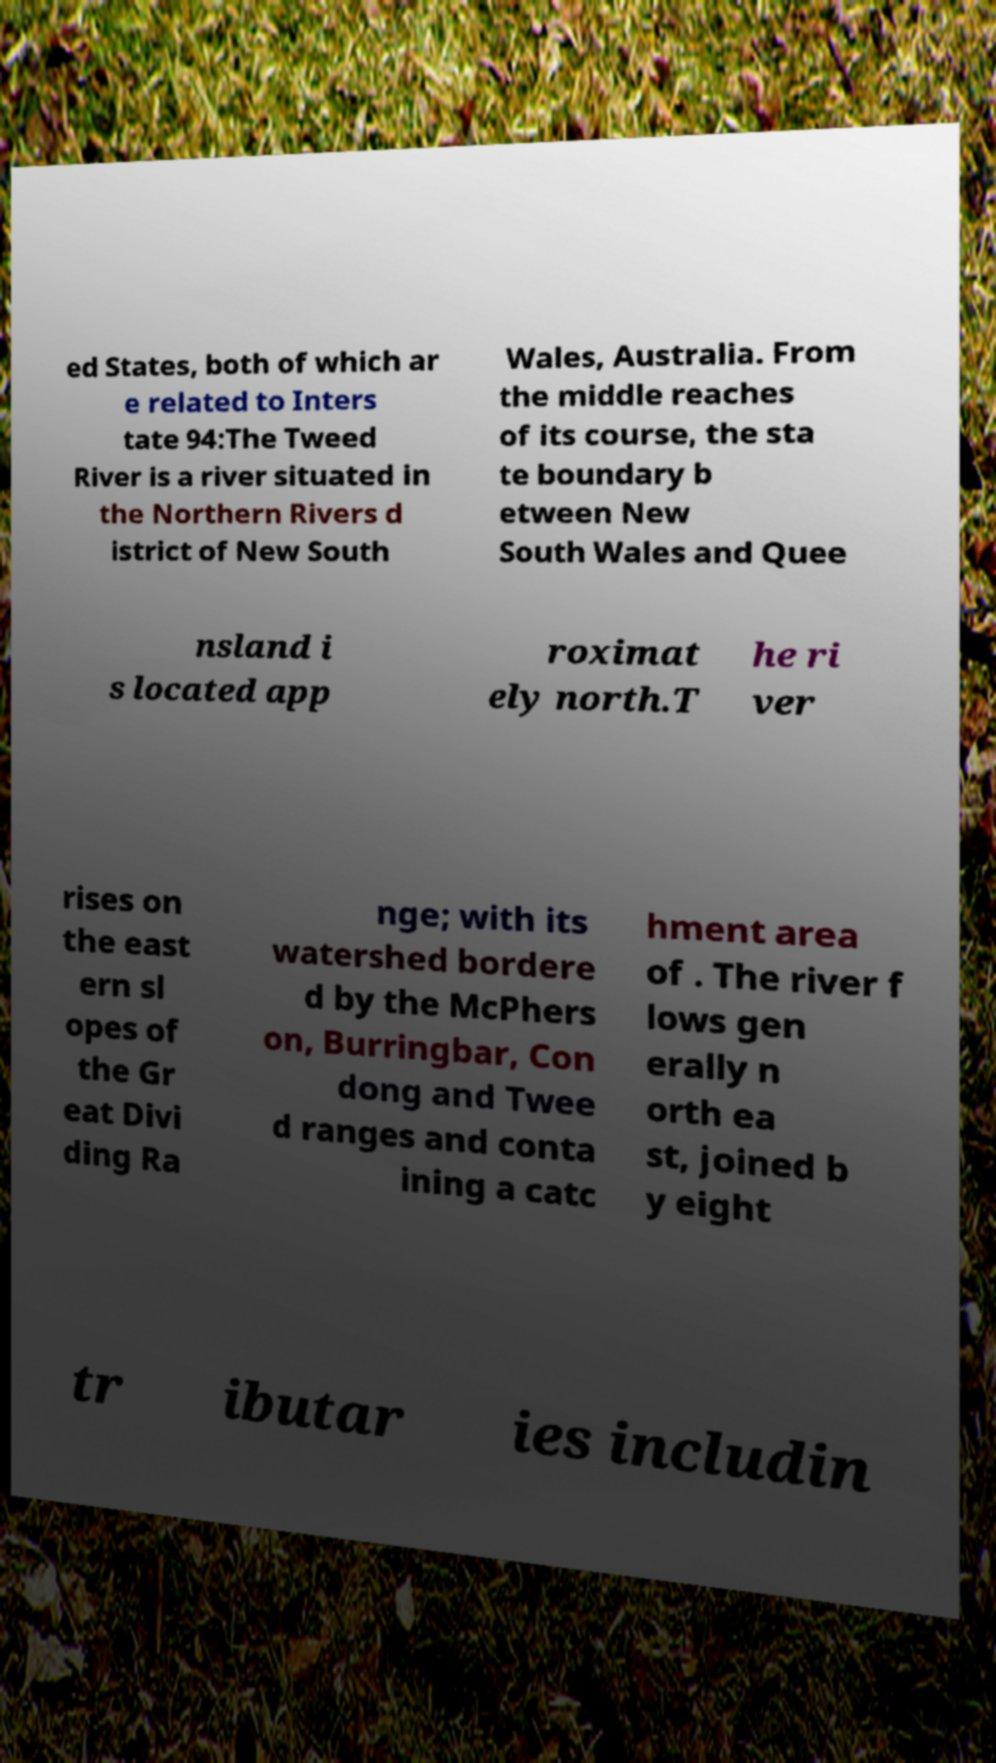There's text embedded in this image that I need extracted. Can you transcribe it verbatim? ed States, both of which ar e related to Inters tate 94:The Tweed River is a river situated in the Northern Rivers d istrict of New South Wales, Australia. From the middle reaches of its course, the sta te boundary b etween New South Wales and Quee nsland i s located app roximat ely north.T he ri ver rises on the east ern sl opes of the Gr eat Divi ding Ra nge; with its watershed bordere d by the McPhers on, Burringbar, Con dong and Twee d ranges and conta ining a catc hment area of . The river f lows gen erally n orth ea st, joined b y eight tr ibutar ies includin 